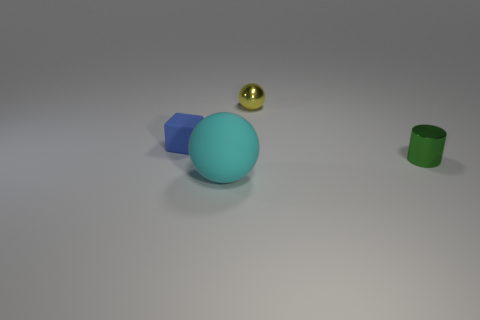Add 2 small matte cubes. How many objects exist? 6 Subtract all cylinders. How many objects are left? 3 Subtract 0 purple balls. How many objects are left? 4 Subtract all gray matte objects. Subtract all small yellow things. How many objects are left? 3 Add 2 cyan matte things. How many cyan matte things are left? 3 Add 2 tiny balls. How many tiny balls exist? 3 